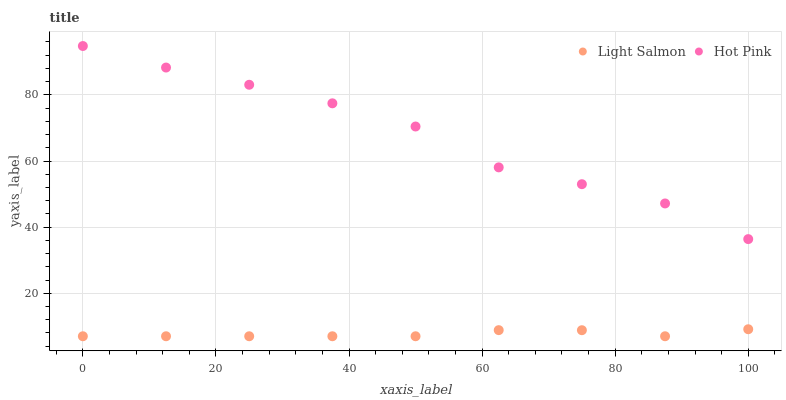Does Light Salmon have the minimum area under the curve?
Answer yes or no. Yes. Does Hot Pink have the maximum area under the curve?
Answer yes or no. Yes. Does Hot Pink have the minimum area under the curve?
Answer yes or no. No. Is Light Salmon the smoothest?
Answer yes or no. Yes. Is Hot Pink the roughest?
Answer yes or no. Yes. Is Hot Pink the smoothest?
Answer yes or no. No. Does Light Salmon have the lowest value?
Answer yes or no. Yes. Does Hot Pink have the lowest value?
Answer yes or no. No. Does Hot Pink have the highest value?
Answer yes or no. Yes. Is Light Salmon less than Hot Pink?
Answer yes or no. Yes. Is Hot Pink greater than Light Salmon?
Answer yes or no. Yes. Does Light Salmon intersect Hot Pink?
Answer yes or no. No. 